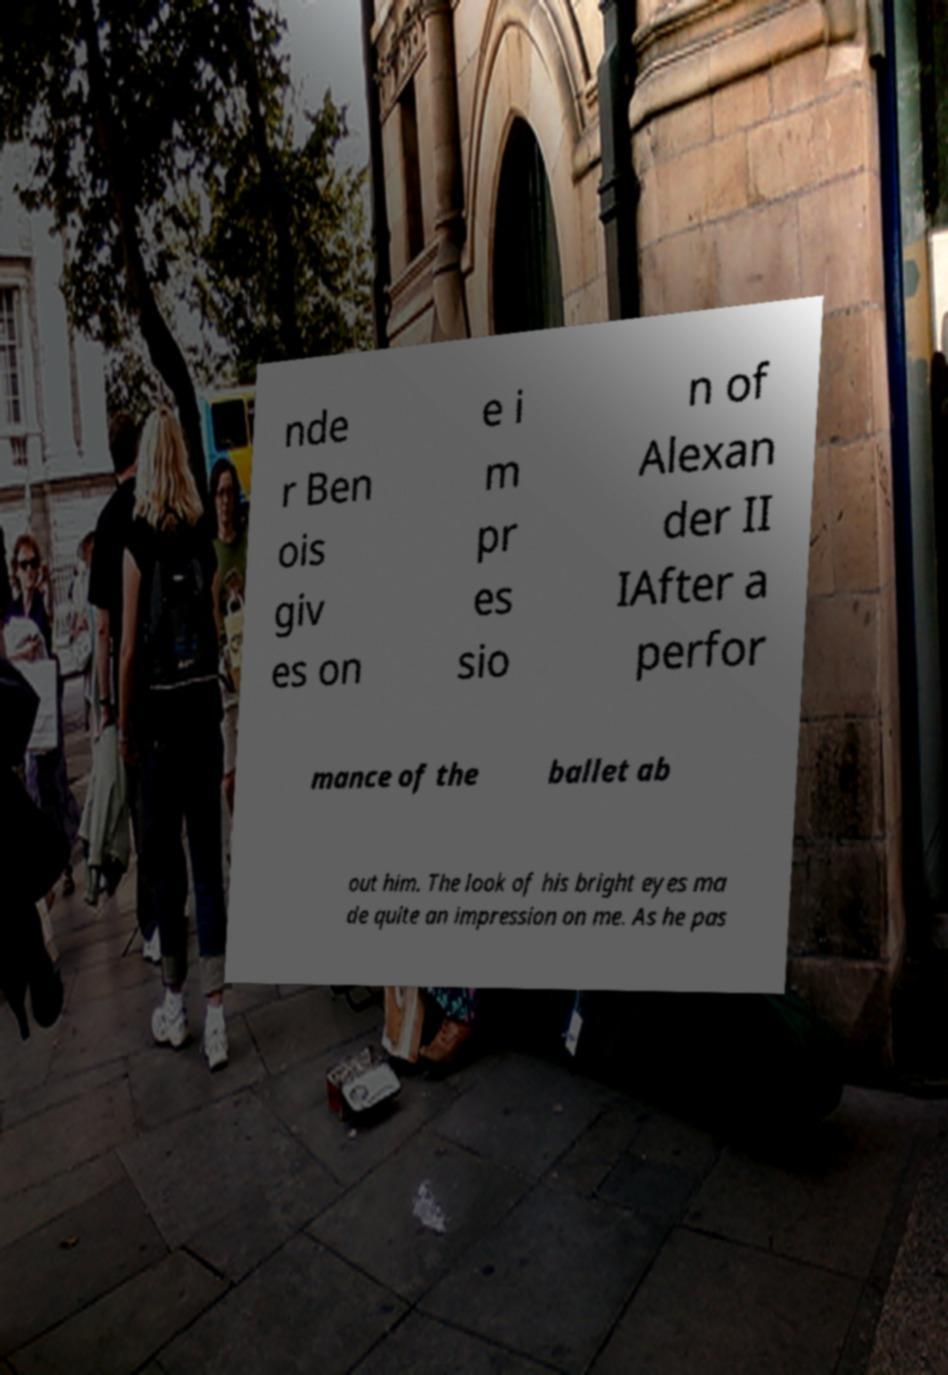Could you extract and type out the text from this image? nde r Ben ois giv es on e i m pr es sio n of Alexan der II IAfter a perfor mance of the ballet ab out him. The look of his bright eyes ma de quite an impression on me. As he pas 